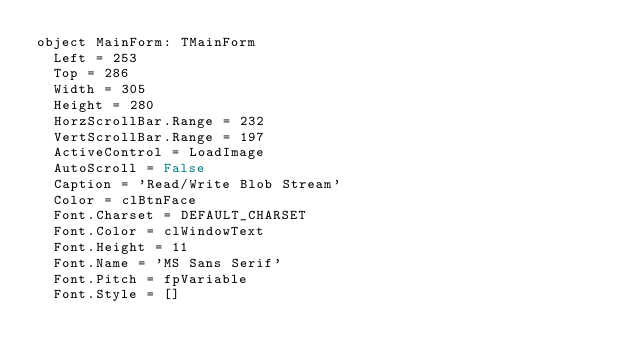<code> <loc_0><loc_0><loc_500><loc_500><_Pascal_>object MainForm: TMainForm
  Left = 253
  Top = 286
  Width = 305
  Height = 280
  HorzScrollBar.Range = 232
  VertScrollBar.Range = 197
  ActiveControl = LoadImage
  AutoScroll = False
  Caption = 'Read/Write Blob Stream'
  Color = clBtnFace
  Font.Charset = DEFAULT_CHARSET
  Font.Color = clWindowText
  Font.Height = 11
  Font.Name = 'MS Sans Serif'
  Font.Pitch = fpVariable
  Font.Style = []</code> 